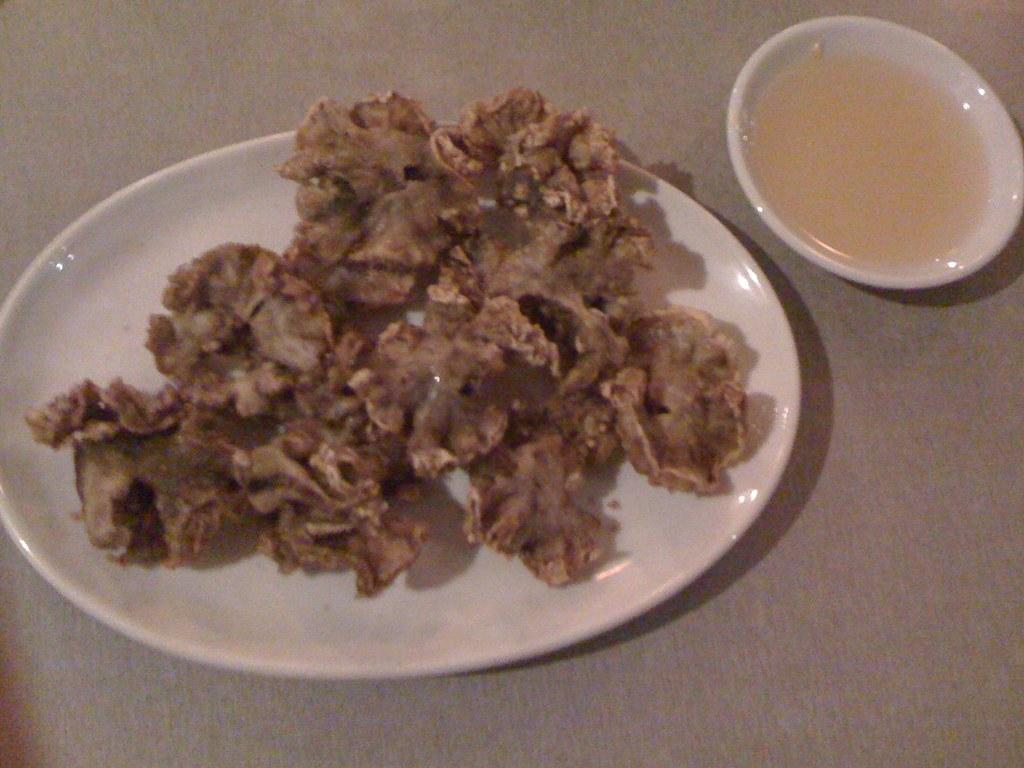How would you summarize this image in a sentence or two? In the image there is some fried item kept on a plate and beside that there is some sauce served in a small bowl. 